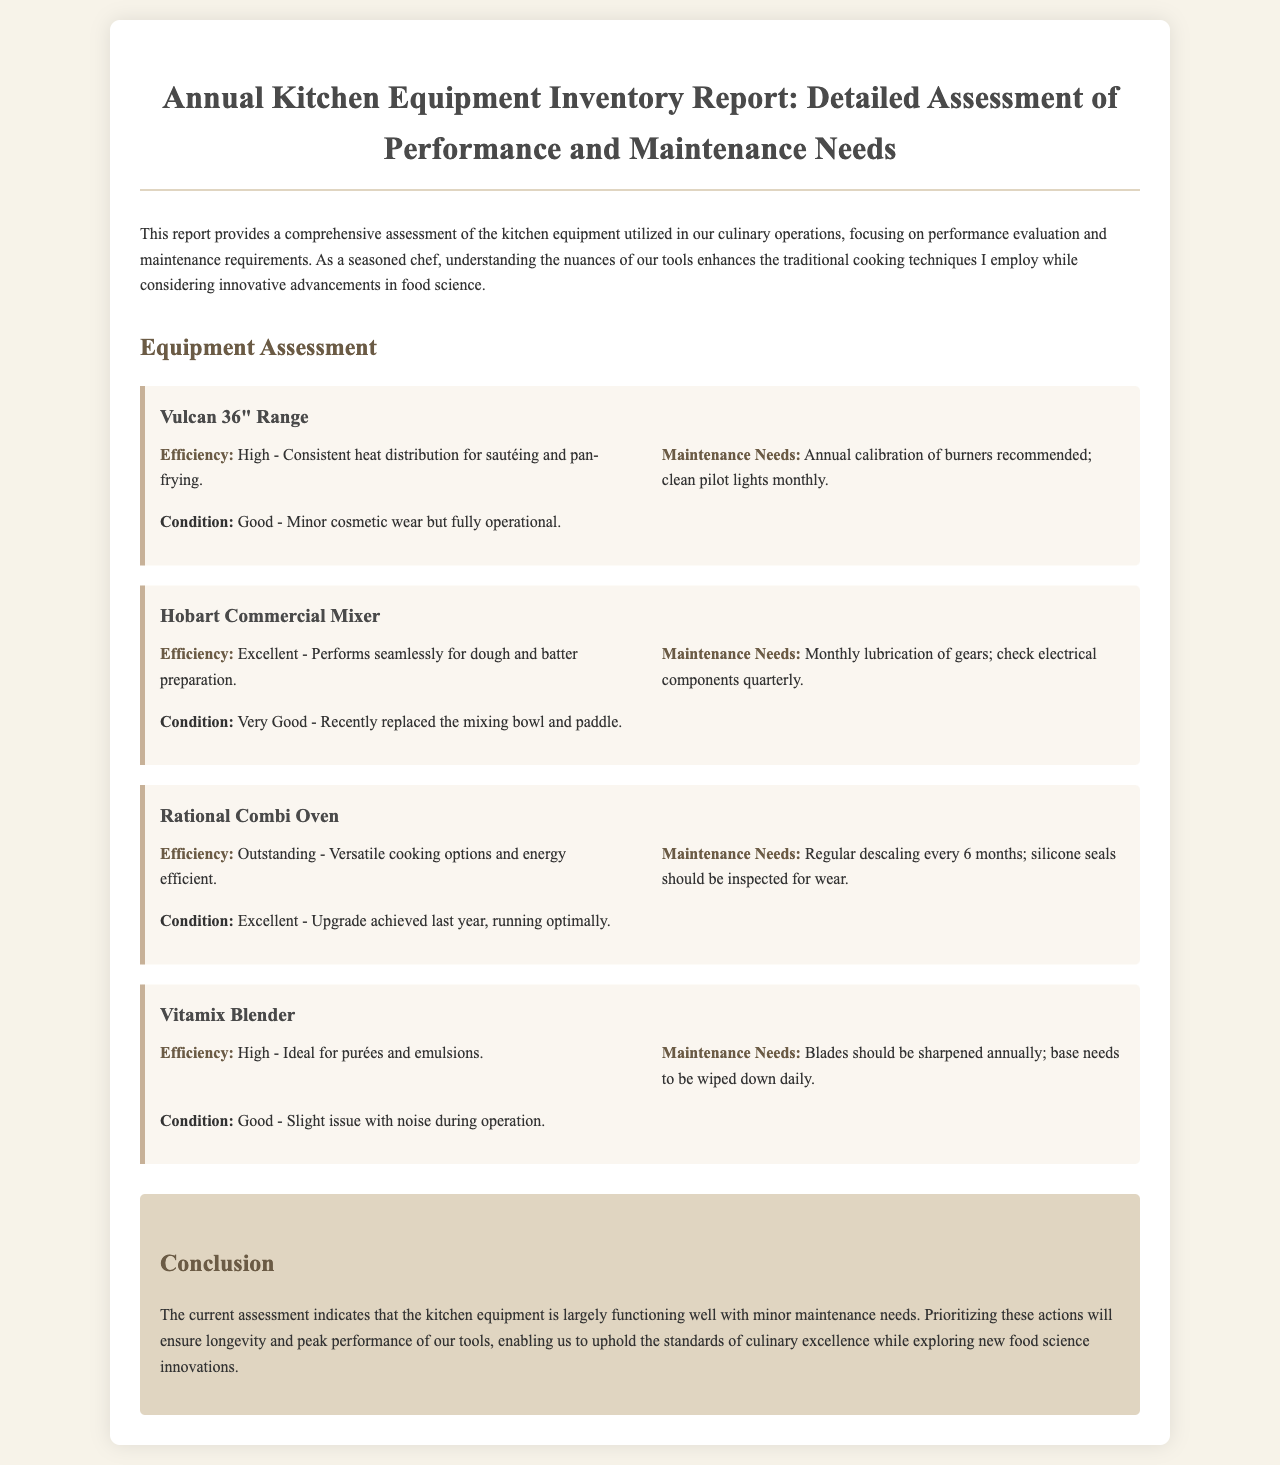What is the title of the report? The title of the report is stated at the top of the document, summarizing its focus on kitchen equipment assessment.
Answer: Annual Kitchen Equipment Inventory Report: Detailed Assessment of Performance and Maintenance Needs Which equipment requires annual calibration? The report lists the maintenance needs for each piece of equipment, specifying which require annual calibration.
Answer: Vulcan 36" Range What is the efficiency rating of the Rational Combi Oven? The efficiency rating for the Rational Combi Oven is provided, highlighting its performance during usage.
Answer: Outstanding How often should the Vitamix Blender blades be sharpened? The maintenance section of the report includes a specific frequency for sharpening the blades of the Vitamix Blender.
Answer: Annually What is the condition of the Hobart Commercial Mixer? The report mentions the condition of the Hobart Commercial Mixer, providing an assessment of its operational state.
Answer: Very Good What is the recommended maintenance for the Rational Combi Oven? The report includes detailed maintenance suggestions for each equipment, particularly for the Rational Combi Oven.
Answer: Regular descaling every 6 months What is highlighted as the conclusion of the report? The conclusion summarizes the overall assessment of kitchen equipment, emphasizing maintenance needs and performance.
Answer: The kitchen equipment is largely functioning well with minor maintenance needs 